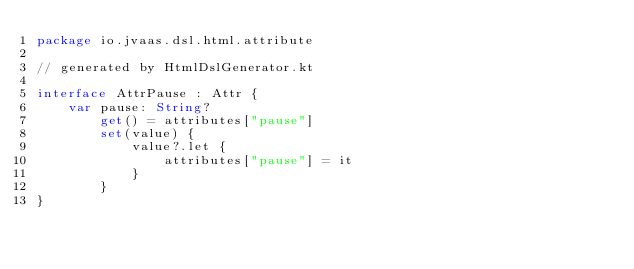<code> <loc_0><loc_0><loc_500><loc_500><_Kotlin_>package io.jvaas.dsl.html.attribute

// generated by HtmlDslGenerator.kt

interface AttrPause : Attr {
	var pause: String?
		get() = attributes["pause"]
		set(value) {
			value?.let {
				attributes["pause"] = it
			}
		}
}	
</code> 